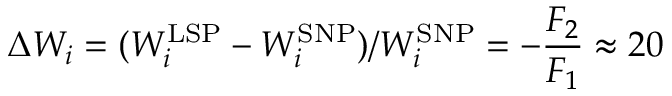Convert formula to latex. <formula><loc_0><loc_0><loc_500><loc_500>\Delta W _ { i } = ( W _ { i } ^ { L S P } - W _ { i } ^ { S N P } ) / W _ { i } ^ { S N P } = - \frac { F _ { 2 } } { F _ { 1 } } \approx 2 0 \</formula> 